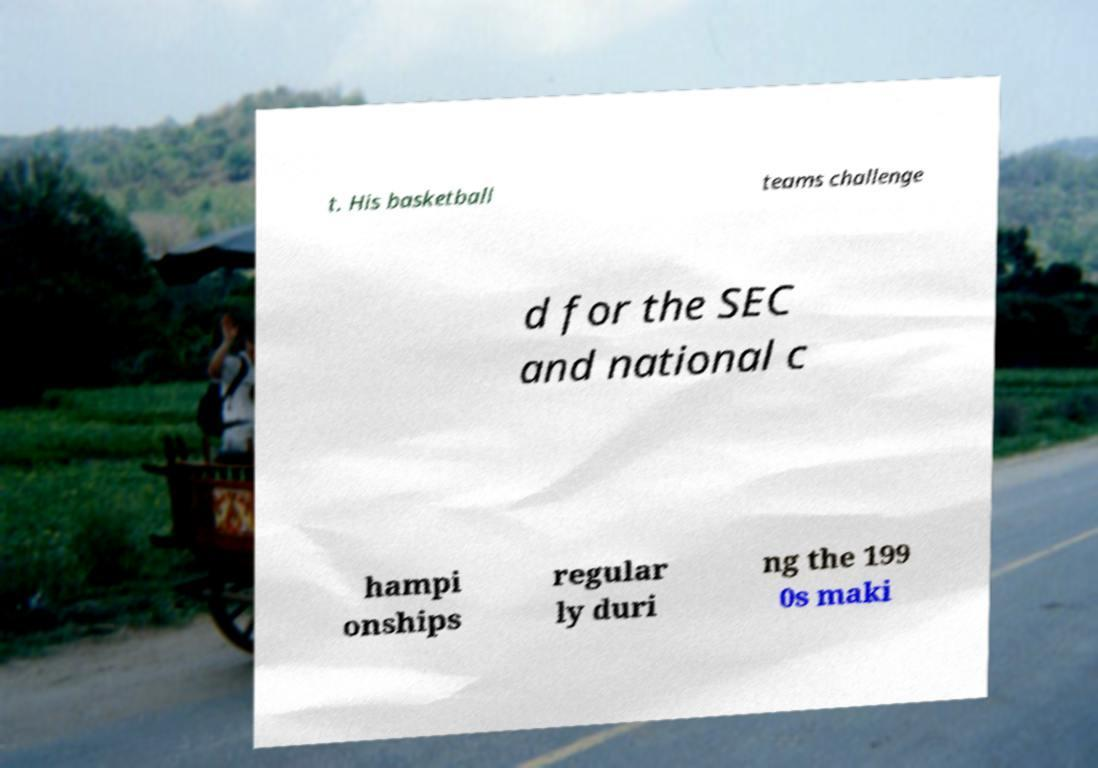Can you accurately transcribe the text from the provided image for me? t. His basketball teams challenge d for the SEC and national c hampi onships regular ly duri ng the 199 0s maki 